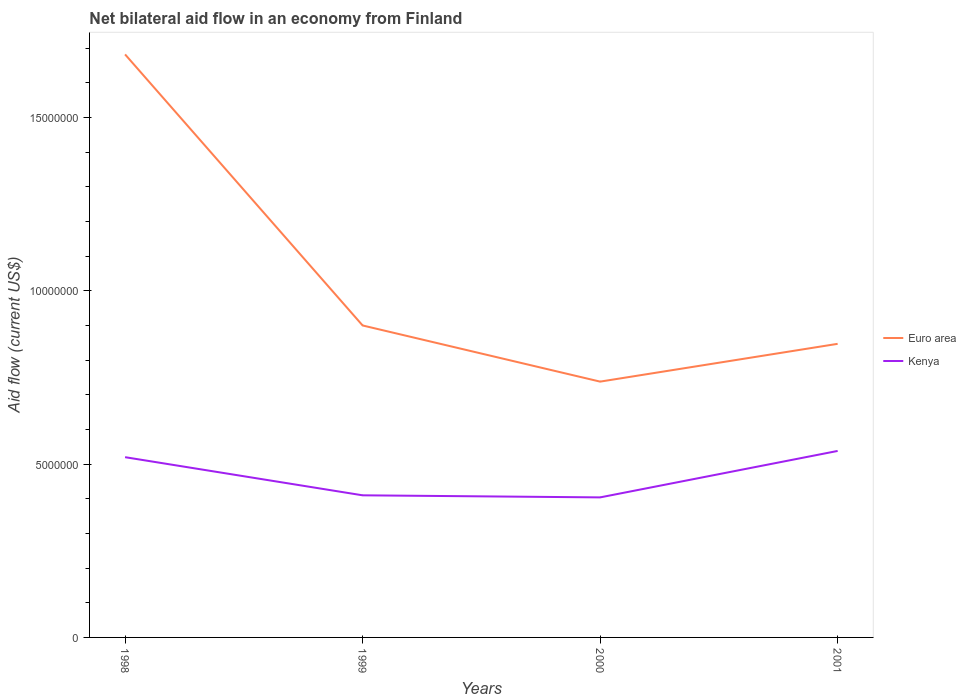How many different coloured lines are there?
Ensure brevity in your answer.  2. Does the line corresponding to Euro area intersect with the line corresponding to Kenya?
Your response must be concise. No. Is the number of lines equal to the number of legend labels?
Provide a succinct answer. Yes. Across all years, what is the maximum net bilateral aid flow in Kenya?
Your answer should be compact. 4.04e+06. In which year was the net bilateral aid flow in Euro area maximum?
Give a very brief answer. 2000. What is the total net bilateral aid flow in Euro area in the graph?
Offer a terse response. 7.82e+06. What is the difference between the highest and the second highest net bilateral aid flow in Kenya?
Give a very brief answer. 1.34e+06. What is the difference between two consecutive major ticks on the Y-axis?
Provide a short and direct response. 5.00e+06. How are the legend labels stacked?
Make the answer very short. Vertical. What is the title of the graph?
Make the answer very short. Net bilateral aid flow in an economy from Finland. Does "Saudi Arabia" appear as one of the legend labels in the graph?
Provide a succinct answer. No. What is the label or title of the X-axis?
Your response must be concise. Years. What is the label or title of the Y-axis?
Give a very brief answer. Aid flow (current US$). What is the Aid flow (current US$) of Euro area in 1998?
Your answer should be compact. 1.68e+07. What is the Aid flow (current US$) in Kenya in 1998?
Provide a short and direct response. 5.20e+06. What is the Aid flow (current US$) of Euro area in 1999?
Keep it short and to the point. 9.00e+06. What is the Aid flow (current US$) of Kenya in 1999?
Keep it short and to the point. 4.10e+06. What is the Aid flow (current US$) of Euro area in 2000?
Provide a succinct answer. 7.38e+06. What is the Aid flow (current US$) in Kenya in 2000?
Offer a very short reply. 4.04e+06. What is the Aid flow (current US$) of Euro area in 2001?
Your response must be concise. 8.47e+06. What is the Aid flow (current US$) in Kenya in 2001?
Offer a very short reply. 5.38e+06. Across all years, what is the maximum Aid flow (current US$) of Euro area?
Your answer should be very brief. 1.68e+07. Across all years, what is the maximum Aid flow (current US$) of Kenya?
Offer a terse response. 5.38e+06. Across all years, what is the minimum Aid flow (current US$) in Euro area?
Keep it short and to the point. 7.38e+06. Across all years, what is the minimum Aid flow (current US$) in Kenya?
Offer a very short reply. 4.04e+06. What is the total Aid flow (current US$) of Euro area in the graph?
Your answer should be compact. 4.17e+07. What is the total Aid flow (current US$) of Kenya in the graph?
Provide a short and direct response. 1.87e+07. What is the difference between the Aid flow (current US$) of Euro area in 1998 and that in 1999?
Offer a very short reply. 7.82e+06. What is the difference between the Aid flow (current US$) in Kenya in 1998 and that in 1999?
Offer a terse response. 1.10e+06. What is the difference between the Aid flow (current US$) of Euro area in 1998 and that in 2000?
Ensure brevity in your answer.  9.44e+06. What is the difference between the Aid flow (current US$) of Kenya in 1998 and that in 2000?
Make the answer very short. 1.16e+06. What is the difference between the Aid flow (current US$) of Euro area in 1998 and that in 2001?
Keep it short and to the point. 8.35e+06. What is the difference between the Aid flow (current US$) in Kenya in 1998 and that in 2001?
Offer a terse response. -1.80e+05. What is the difference between the Aid flow (current US$) of Euro area in 1999 and that in 2000?
Give a very brief answer. 1.62e+06. What is the difference between the Aid flow (current US$) of Kenya in 1999 and that in 2000?
Provide a short and direct response. 6.00e+04. What is the difference between the Aid flow (current US$) in Euro area in 1999 and that in 2001?
Keep it short and to the point. 5.30e+05. What is the difference between the Aid flow (current US$) of Kenya in 1999 and that in 2001?
Provide a short and direct response. -1.28e+06. What is the difference between the Aid flow (current US$) in Euro area in 2000 and that in 2001?
Ensure brevity in your answer.  -1.09e+06. What is the difference between the Aid flow (current US$) in Kenya in 2000 and that in 2001?
Your answer should be compact. -1.34e+06. What is the difference between the Aid flow (current US$) of Euro area in 1998 and the Aid flow (current US$) of Kenya in 1999?
Provide a succinct answer. 1.27e+07. What is the difference between the Aid flow (current US$) in Euro area in 1998 and the Aid flow (current US$) in Kenya in 2000?
Ensure brevity in your answer.  1.28e+07. What is the difference between the Aid flow (current US$) of Euro area in 1998 and the Aid flow (current US$) of Kenya in 2001?
Offer a very short reply. 1.14e+07. What is the difference between the Aid flow (current US$) in Euro area in 1999 and the Aid flow (current US$) in Kenya in 2000?
Keep it short and to the point. 4.96e+06. What is the difference between the Aid flow (current US$) in Euro area in 1999 and the Aid flow (current US$) in Kenya in 2001?
Provide a succinct answer. 3.62e+06. What is the difference between the Aid flow (current US$) of Euro area in 2000 and the Aid flow (current US$) of Kenya in 2001?
Provide a short and direct response. 2.00e+06. What is the average Aid flow (current US$) of Euro area per year?
Your answer should be compact. 1.04e+07. What is the average Aid flow (current US$) in Kenya per year?
Provide a short and direct response. 4.68e+06. In the year 1998, what is the difference between the Aid flow (current US$) of Euro area and Aid flow (current US$) of Kenya?
Provide a short and direct response. 1.16e+07. In the year 1999, what is the difference between the Aid flow (current US$) of Euro area and Aid flow (current US$) of Kenya?
Ensure brevity in your answer.  4.90e+06. In the year 2000, what is the difference between the Aid flow (current US$) in Euro area and Aid flow (current US$) in Kenya?
Offer a very short reply. 3.34e+06. In the year 2001, what is the difference between the Aid flow (current US$) of Euro area and Aid flow (current US$) of Kenya?
Your answer should be compact. 3.09e+06. What is the ratio of the Aid flow (current US$) of Euro area in 1998 to that in 1999?
Your answer should be very brief. 1.87. What is the ratio of the Aid flow (current US$) of Kenya in 1998 to that in 1999?
Give a very brief answer. 1.27. What is the ratio of the Aid flow (current US$) of Euro area in 1998 to that in 2000?
Provide a succinct answer. 2.28. What is the ratio of the Aid flow (current US$) of Kenya in 1998 to that in 2000?
Ensure brevity in your answer.  1.29. What is the ratio of the Aid flow (current US$) in Euro area in 1998 to that in 2001?
Keep it short and to the point. 1.99. What is the ratio of the Aid flow (current US$) of Kenya in 1998 to that in 2001?
Provide a short and direct response. 0.97. What is the ratio of the Aid flow (current US$) in Euro area in 1999 to that in 2000?
Ensure brevity in your answer.  1.22. What is the ratio of the Aid flow (current US$) of Kenya in 1999 to that in 2000?
Your answer should be very brief. 1.01. What is the ratio of the Aid flow (current US$) of Euro area in 1999 to that in 2001?
Provide a short and direct response. 1.06. What is the ratio of the Aid flow (current US$) in Kenya in 1999 to that in 2001?
Your answer should be compact. 0.76. What is the ratio of the Aid flow (current US$) in Euro area in 2000 to that in 2001?
Ensure brevity in your answer.  0.87. What is the ratio of the Aid flow (current US$) of Kenya in 2000 to that in 2001?
Your answer should be compact. 0.75. What is the difference between the highest and the second highest Aid flow (current US$) in Euro area?
Give a very brief answer. 7.82e+06. What is the difference between the highest and the second highest Aid flow (current US$) in Kenya?
Give a very brief answer. 1.80e+05. What is the difference between the highest and the lowest Aid flow (current US$) in Euro area?
Give a very brief answer. 9.44e+06. What is the difference between the highest and the lowest Aid flow (current US$) in Kenya?
Keep it short and to the point. 1.34e+06. 